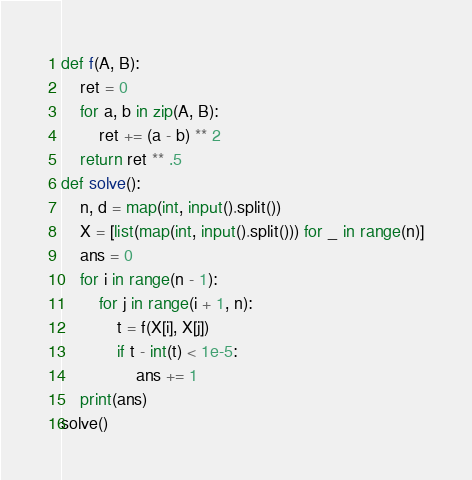<code> <loc_0><loc_0><loc_500><loc_500><_Python_>def f(A, B):
    ret = 0
    for a, b in zip(A, B):
        ret += (a - b) ** 2
    return ret ** .5
def solve():
    n, d = map(int, input().split())
    X = [list(map(int, input().split())) for _ in range(n)]
    ans = 0
    for i in range(n - 1):
        for j in range(i + 1, n):
            t = f(X[i], X[j])
            if t - int(t) < 1e-5:
                ans += 1
    print(ans)
solve()
</code> 